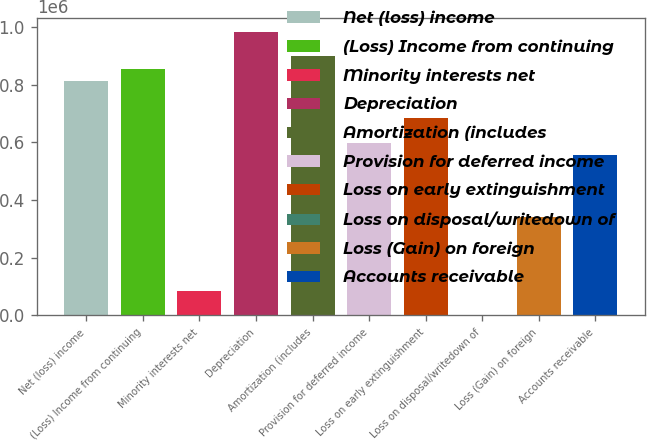Convert chart. <chart><loc_0><loc_0><loc_500><loc_500><bar_chart><fcel>Net (loss) income<fcel>(Loss) Income from continuing<fcel>Minority interests net<fcel>Depreciation<fcel>Amortization (includes<fcel>Provision for deferred income<fcel>Loss on early extinguishment<fcel>Loss on disposal/writedown of<fcel>Loss (Gain) on foreign<fcel>Accounts receivable<nl><fcel>812768<fcel>855528<fcel>85840.8<fcel>983809<fcel>898288<fcel>598966<fcel>684486<fcel>320<fcel>342403<fcel>556205<nl></chart> 